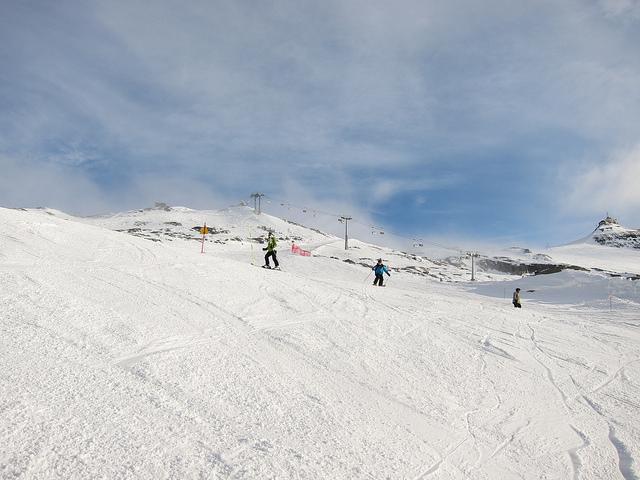What activity are the people in the picture doing?
Short answer required. Skiing. Are they downhill or cross country skiing?
Be succinct. Downhill. Are the people cross country skiing?
Keep it brief. No. What season is it in the picture?
Keep it brief. Winter. 